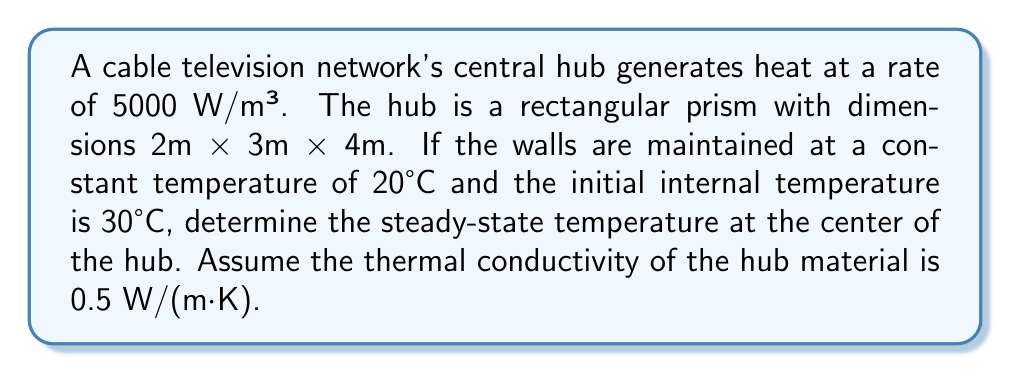Can you answer this question? To solve this problem, we'll use the steady-state heat equation in three dimensions:

$$\frac{\partial^2 T}{\partial x^2} + \frac{\partial^2 T}{\partial y^2} + \frac{\partial^2 T}{\partial z^2} + \frac{q}{k} = 0$$

Where:
- $T$ is temperature
- $q$ is the heat generation rate per unit volume
- $k$ is the thermal conductivity

For a rectangular prism with dimensions $2a \times 2b \times 2c$, the solution is:

$$T(x,y,z) = T_0 + \frac{q}{2k}\left(a^2 - x^2 + b^2 - y^2 + c^2 - z^2\right)$$

Where $T_0$ is the wall temperature.

Given:
- $q = 5000$ W/m³
- $k = 0.5$ W/(m·K)
- $a = 1$ m, $b = 1.5$ m, $c = 2$ m
- $T_0 = 20°C$

Substituting these values into the equation for the center point (0, 0, 0):

$$\begin{align}
T(0,0,0) &= 20 + \frac{5000}{2(0.5)}(1^2 + 1.5^2 + 2^2) \\
&= 20 + 5000(1 + 2.25 + 4) \\
&= 20 + 5000(7.25) \\
&= 20 + 36250 \\
&= 36270°C
\end{align}$$
Answer: 36270°C 